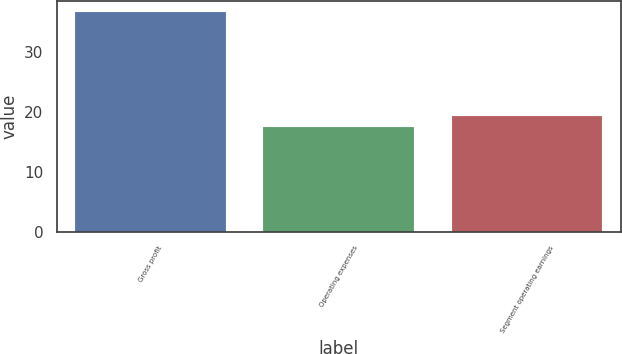Convert chart. <chart><loc_0><loc_0><loc_500><loc_500><bar_chart><fcel>Gross profit<fcel>Operating expenses<fcel>Segment operating earnings<nl><fcel>36.7<fcel>17.4<fcel>19.33<nl></chart> 